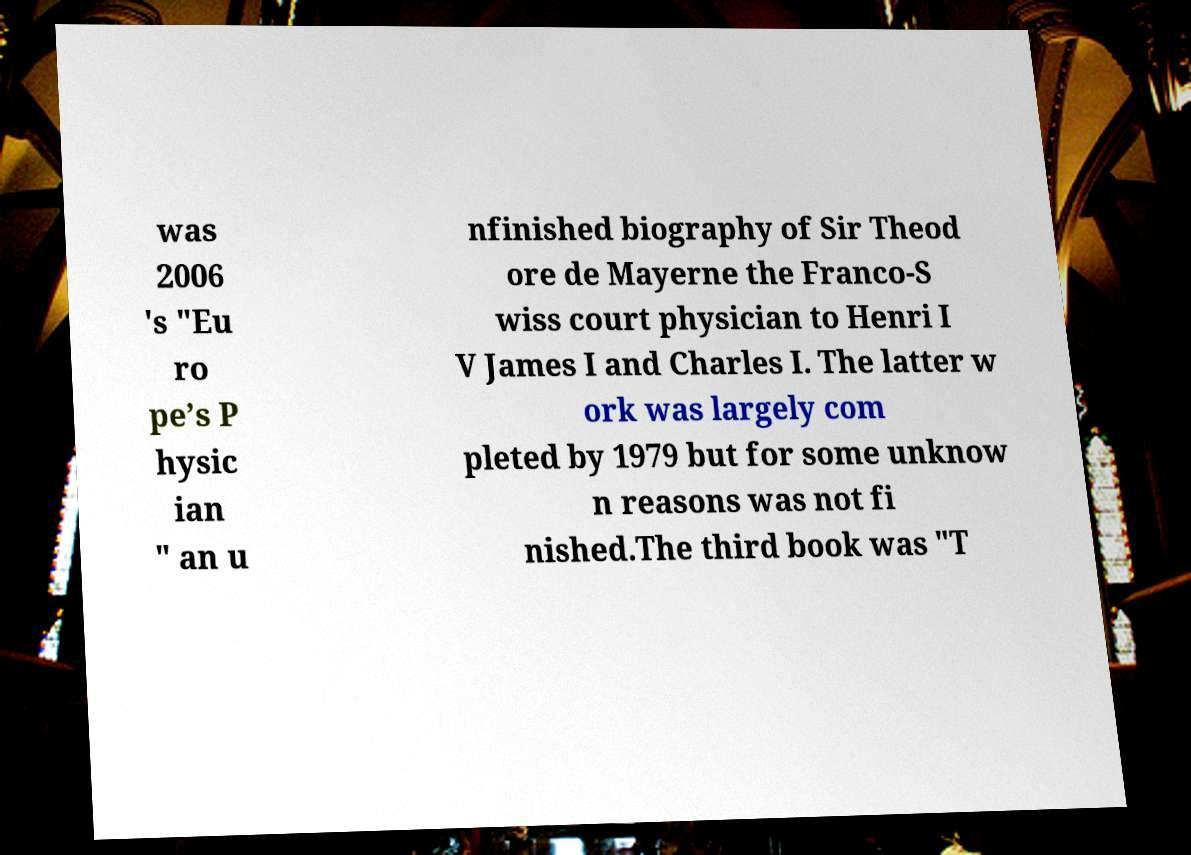I need the written content from this picture converted into text. Can you do that? was 2006 's "Eu ro pe’s P hysic ian " an u nfinished biography of Sir Theod ore de Mayerne the Franco-S wiss court physician to Henri I V James I and Charles I. The latter w ork was largely com pleted by 1979 but for some unknow n reasons was not fi nished.The third book was "T 